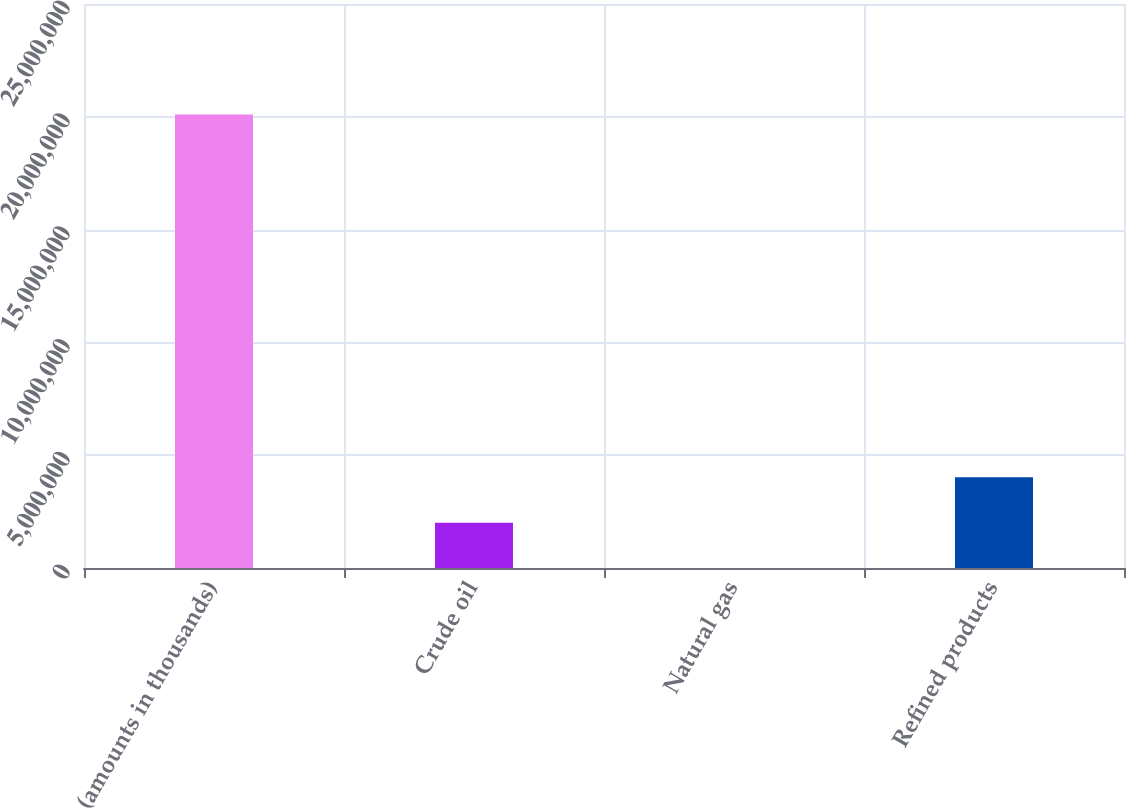Convert chart. <chart><loc_0><loc_0><loc_500><loc_500><bar_chart><fcel>(amounts in thousands)<fcel>Crude oil<fcel>Natural gas<fcel>Refined products<nl><fcel>2.0102e+07<fcel>2.0102e+06<fcel>2<fcel>4.0204e+06<nl></chart> 